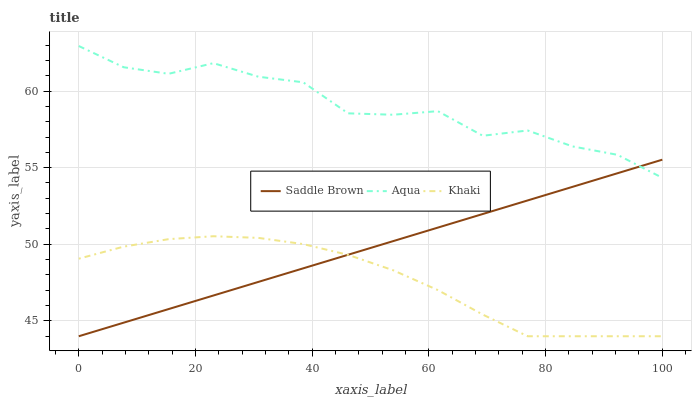Does Saddle Brown have the minimum area under the curve?
Answer yes or no. No. Does Saddle Brown have the maximum area under the curve?
Answer yes or no. No. Is Aqua the smoothest?
Answer yes or no. No. Is Saddle Brown the roughest?
Answer yes or no. No. Does Aqua have the lowest value?
Answer yes or no. No. Does Saddle Brown have the highest value?
Answer yes or no. No. Is Khaki less than Aqua?
Answer yes or no. Yes. Is Aqua greater than Khaki?
Answer yes or no. Yes. Does Khaki intersect Aqua?
Answer yes or no. No. 